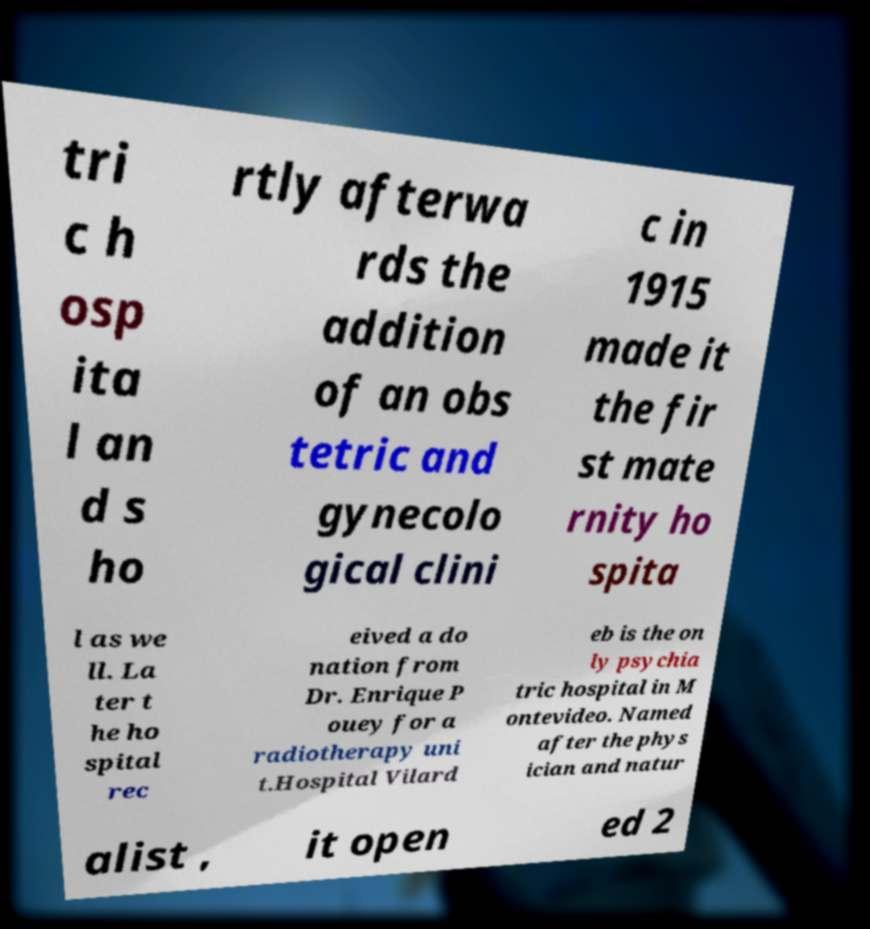For documentation purposes, I need the text within this image transcribed. Could you provide that? tri c h osp ita l an d s ho rtly afterwa rds the addition of an obs tetric and gynecolo gical clini c in 1915 made it the fir st mate rnity ho spita l as we ll. La ter t he ho spital rec eived a do nation from Dr. Enrique P ouey for a radiotherapy uni t.Hospital Vilard eb is the on ly psychia tric hospital in M ontevideo. Named after the phys ician and natur alist , it open ed 2 